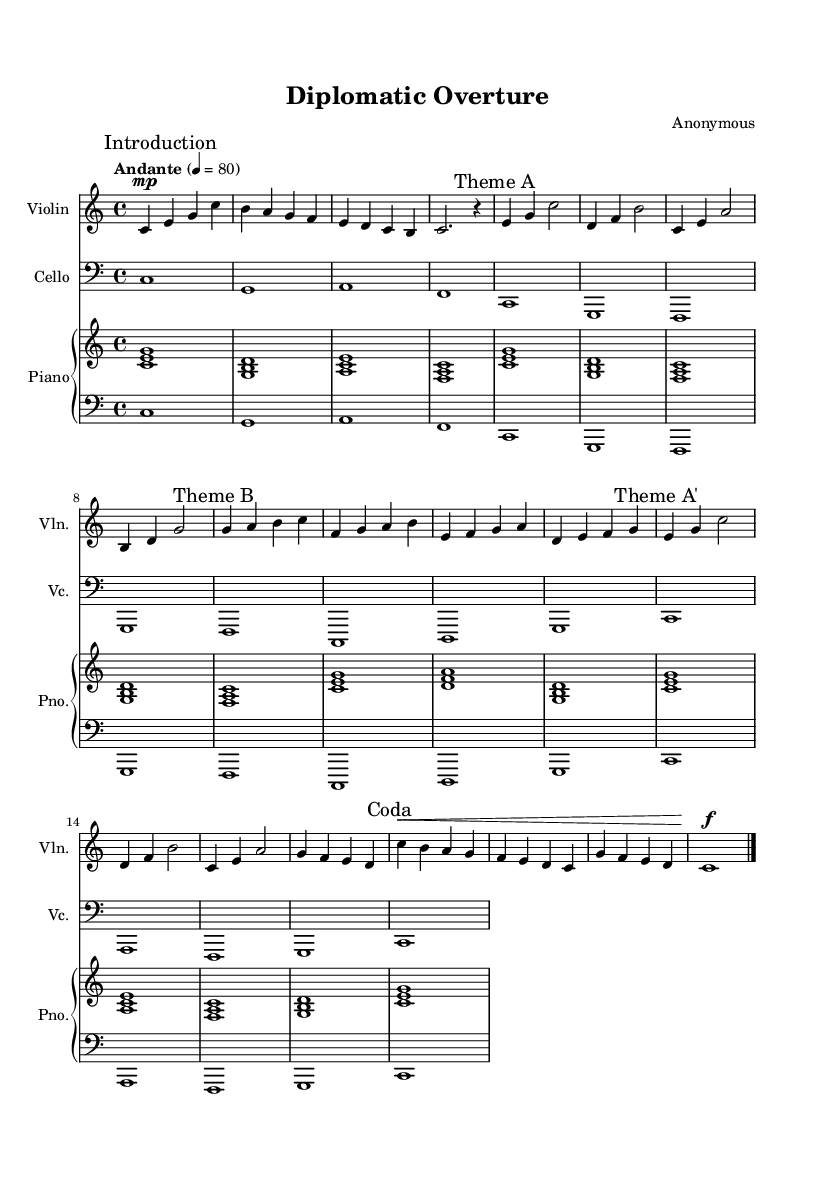What is the key signature of this music? The key signature is C major, indicated by the absence of sharps or flats at the beginning of the staff.
Answer: C major What is the time signature of this piece? The time signature is 4/4, which means there are four beats per measure, and the quarter note gets one beat, as noted at the beginning of the score.
Answer: 4/4 What is the tempo marking of the composition? The tempo marking is "Andante" with a metronome marking of 80 beats per minute, indicated at the start of the score.
Answer: Andante How many distinct themes are present in this piece? There are two distinct themes labeled as Theme A and Theme B, as indicated in the score.
Answer: Two What instruments are featured in this composition? The composition features violin, cello, and piano, as specified at the beginning of each staff.
Answer: Violin, Cello, Piano Which section of the music serves as the introduction? The section labeled "Introduction", which consists of the first four measures, serves as the introductory part of the composition.
Answer: Introduction What dynamic marking is used at the beginning of the violin part? The dynamic marking at the beginning of the violin part is "mp," indicating a moderately soft volume for that section.
Answer: mp 